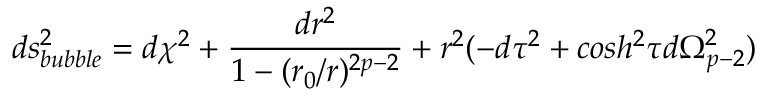<formula> <loc_0><loc_0><loc_500><loc_500>d s _ { b u b b l e } ^ { 2 } = d \chi ^ { 2 } + \frac { d r ^ { 2 } } { 1 - ( r _ { 0 } / r ) ^ { 2 p - 2 } } + r ^ { 2 } ( - d \tau ^ { 2 } + \cosh ^ { 2 } \tau d \Omega _ { p - 2 } ^ { 2 } )</formula> 